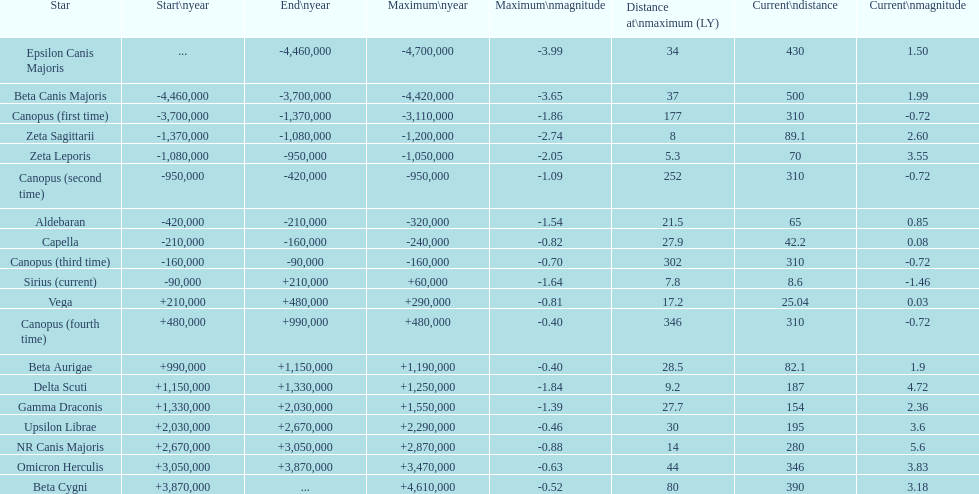0 or greater? 11. 